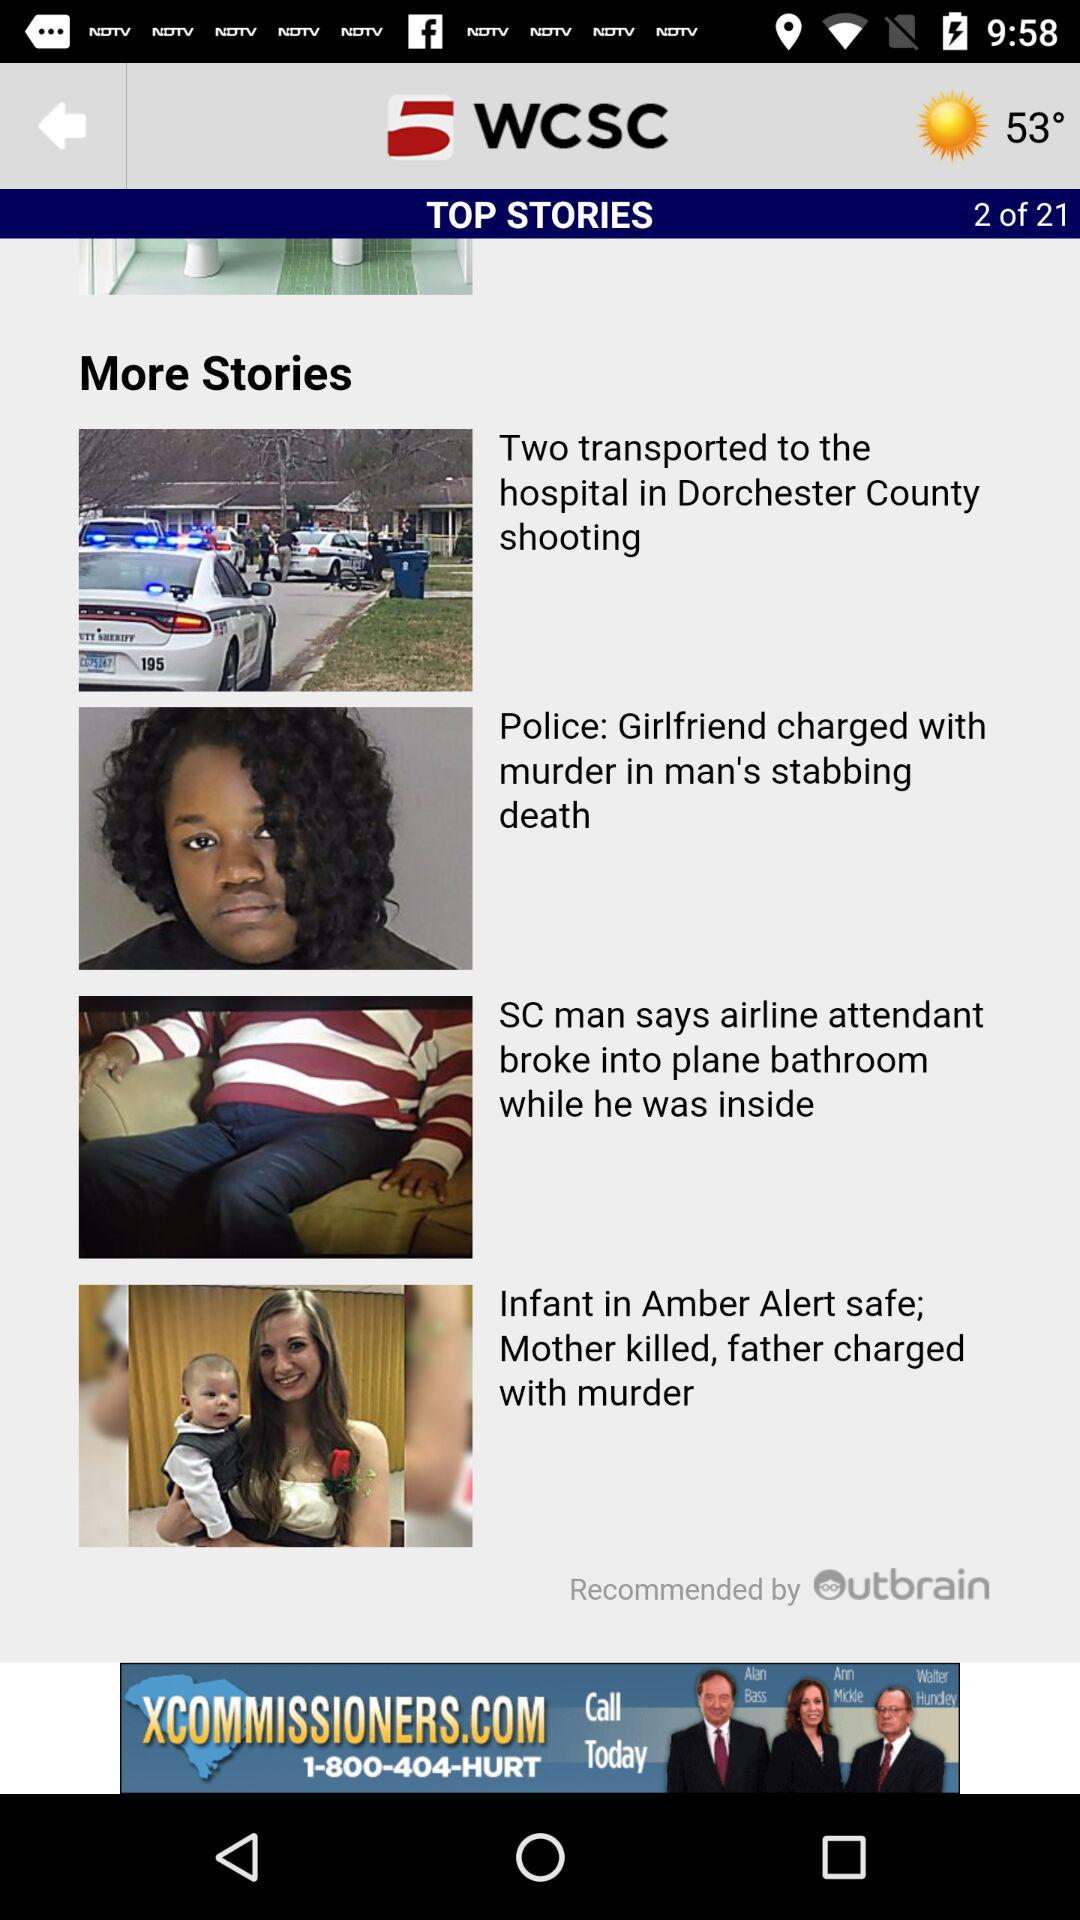By whom is the page recommended? The page is recommended by "Outbrain". 